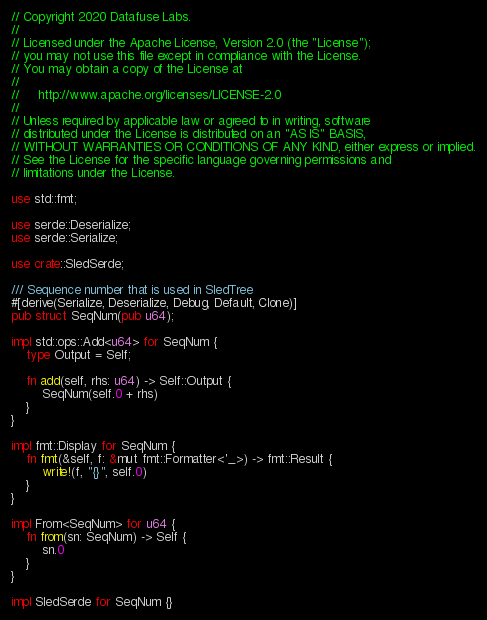<code> <loc_0><loc_0><loc_500><loc_500><_Rust_>// Copyright 2020 Datafuse Labs.
//
// Licensed under the Apache License, Version 2.0 (the "License");
// you may not use this file except in compliance with the License.
// You may obtain a copy of the License at
//
//     http://www.apache.org/licenses/LICENSE-2.0
//
// Unless required by applicable law or agreed to in writing, software
// distributed under the License is distributed on an "AS IS" BASIS,
// WITHOUT WARRANTIES OR CONDITIONS OF ANY KIND, either express or implied.
// See the License for the specific language governing permissions and
// limitations under the License.

use std::fmt;

use serde::Deserialize;
use serde::Serialize;

use crate::SledSerde;

/// Sequence number that is used in SledTree
#[derive(Serialize, Deserialize, Debug, Default, Clone)]
pub struct SeqNum(pub u64);

impl std::ops::Add<u64> for SeqNum {
    type Output = Self;

    fn add(self, rhs: u64) -> Self::Output {
        SeqNum(self.0 + rhs)
    }
}

impl fmt::Display for SeqNum {
    fn fmt(&self, f: &mut fmt::Formatter<'_>) -> fmt::Result {
        write!(f, "{}", self.0)
    }
}

impl From<SeqNum> for u64 {
    fn from(sn: SeqNum) -> Self {
        sn.0
    }
}

impl SledSerde for SeqNum {}
</code> 